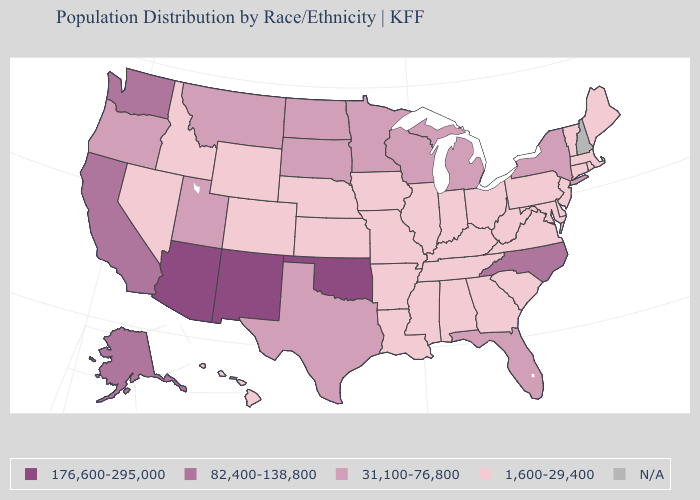Which states have the lowest value in the MidWest?
Write a very short answer. Illinois, Indiana, Iowa, Kansas, Missouri, Nebraska, Ohio. Name the states that have a value in the range 176,600-295,000?
Keep it brief. Arizona, New Mexico, Oklahoma. How many symbols are there in the legend?
Quick response, please. 5. What is the value of Arkansas?
Quick response, please. 1,600-29,400. What is the lowest value in the West?
Write a very short answer. 1,600-29,400. How many symbols are there in the legend?
Be succinct. 5. Which states have the highest value in the USA?
Keep it brief. Arizona, New Mexico, Oklahoma. Name the states that have a value in the range 1,600-29,400?
Concise answer only. Alabama, Arkansas, Colorado, Connecticut, Delaware, Georgia, Hawaii, Idaho, Illinois, Indiana, Iowa, Kansas, Kentucky, Louisiana, Maine, Maryland, Massachusetts, Mississippi, Missouri, Nebraska, Nevada, New Jersey, Ohio, Pennsylvania, Rhode Island, South Carolina, Tennessee, Vermont, Virginia, West Virginia, Wyoming. Name the states that have a value in the range 1,600-29,400?
Concise answer only. Alabama, Arkansas, Colorado, Connecticut, Delaware, Georgia, Hawaii, Idaho, Illinois, Indiana, Iowa, Kansas, Kentucky, Louisiana, Maine, Maryland, Massachusetts, Mississippi, Missouri, Nebraska, Nevada, New Jersey, Ohio, Pennsylvania, Rhode Island, South Carolina, Tennessee, Vermont, Virginia, West Virginia, Wyoming. Name the states that have a value in the range 176,600-295,000?
Keep it brief. Arizona, New Mexico, Oklahoma. Name the states that have a value in the range 82,400-138,800?
Be succinct. Alaska, California, North Carolina, Washington. Among the states that border Arkansas , does Oklahoma have the highest value?
Quick response, please. Yes. Does Minnesota have the highest value in the MidWest?
Quick response, please. Yes. Name the states that have a value in the range 1,600-29,400?
Short answer required. Alabama, Arkansas, Colorado, Connecticut, Delaware, Georgia, Hawaii, Idaho, Illinois, Indiana, Iowa, Kansas, Kentucky, Louisiana, Maine, Maryland, Massachusetts, Mississippi, Missouri, Nebraska, Nevada, New Jersey, Ohio, Pennsylvania, Rhode Island, South Carolina, Tennessee, Vermont, Virginia, West Virginia, Wyoming. 